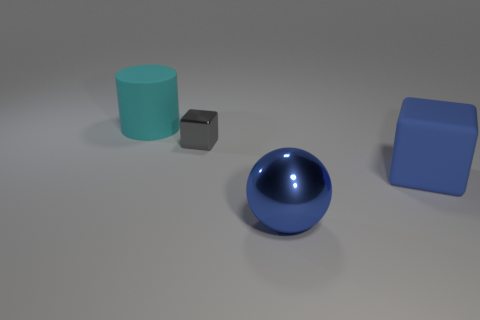Can you describe the sizes of the objects relative to each other? Certainly! The cyan cylinder is the tallest object, followed by the blue cube which is medium-sized. The tiny gray cube is the smallest object, and the blue sphere appears to be of a medium size, with its diameter roughly comparable to the side of the blue cube. 